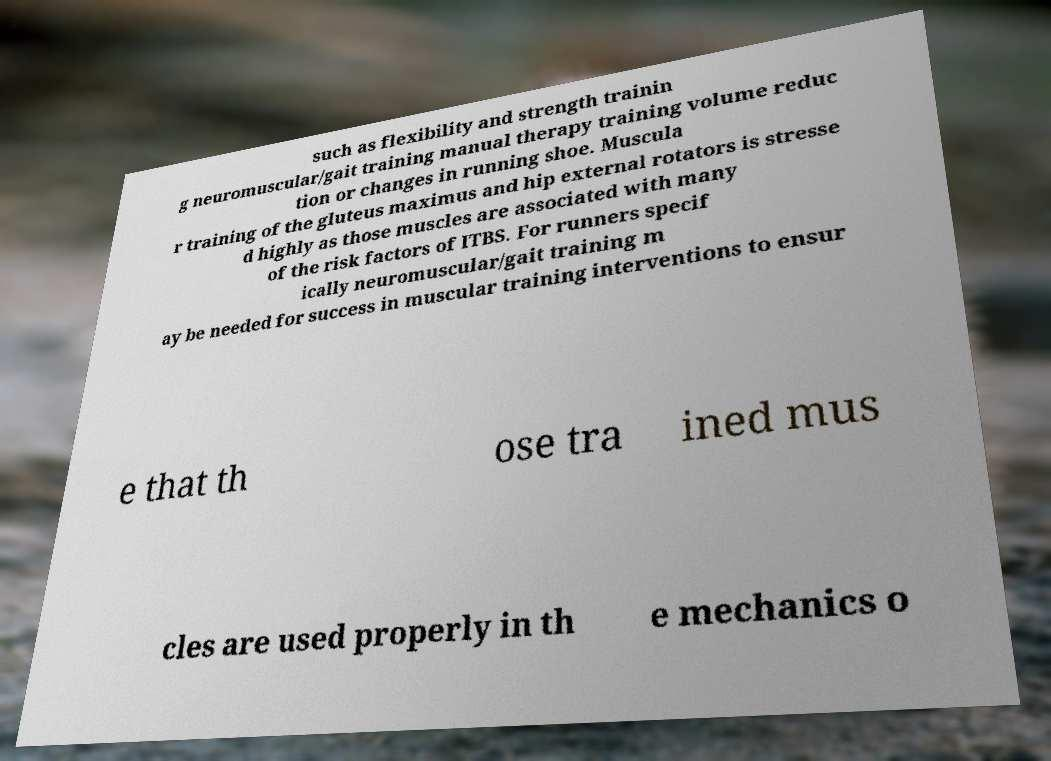I need the written content from this picture converted into text. Can you do that? such as flexibility and strength trainin g neuromuscular/gait training manual therapy training volume reduc tion or changes in running shoe. Muscula r training of the gluteus maximus and hip external rotators is stresse d highly as those muscles are associated with many of the risk factors of ITBS. For runners specif ically neuromuscular/gait training m ay be needed for success in muscular training interventions to ensur e that th ose tra ined mus cles are used properly in th e mechanics o 